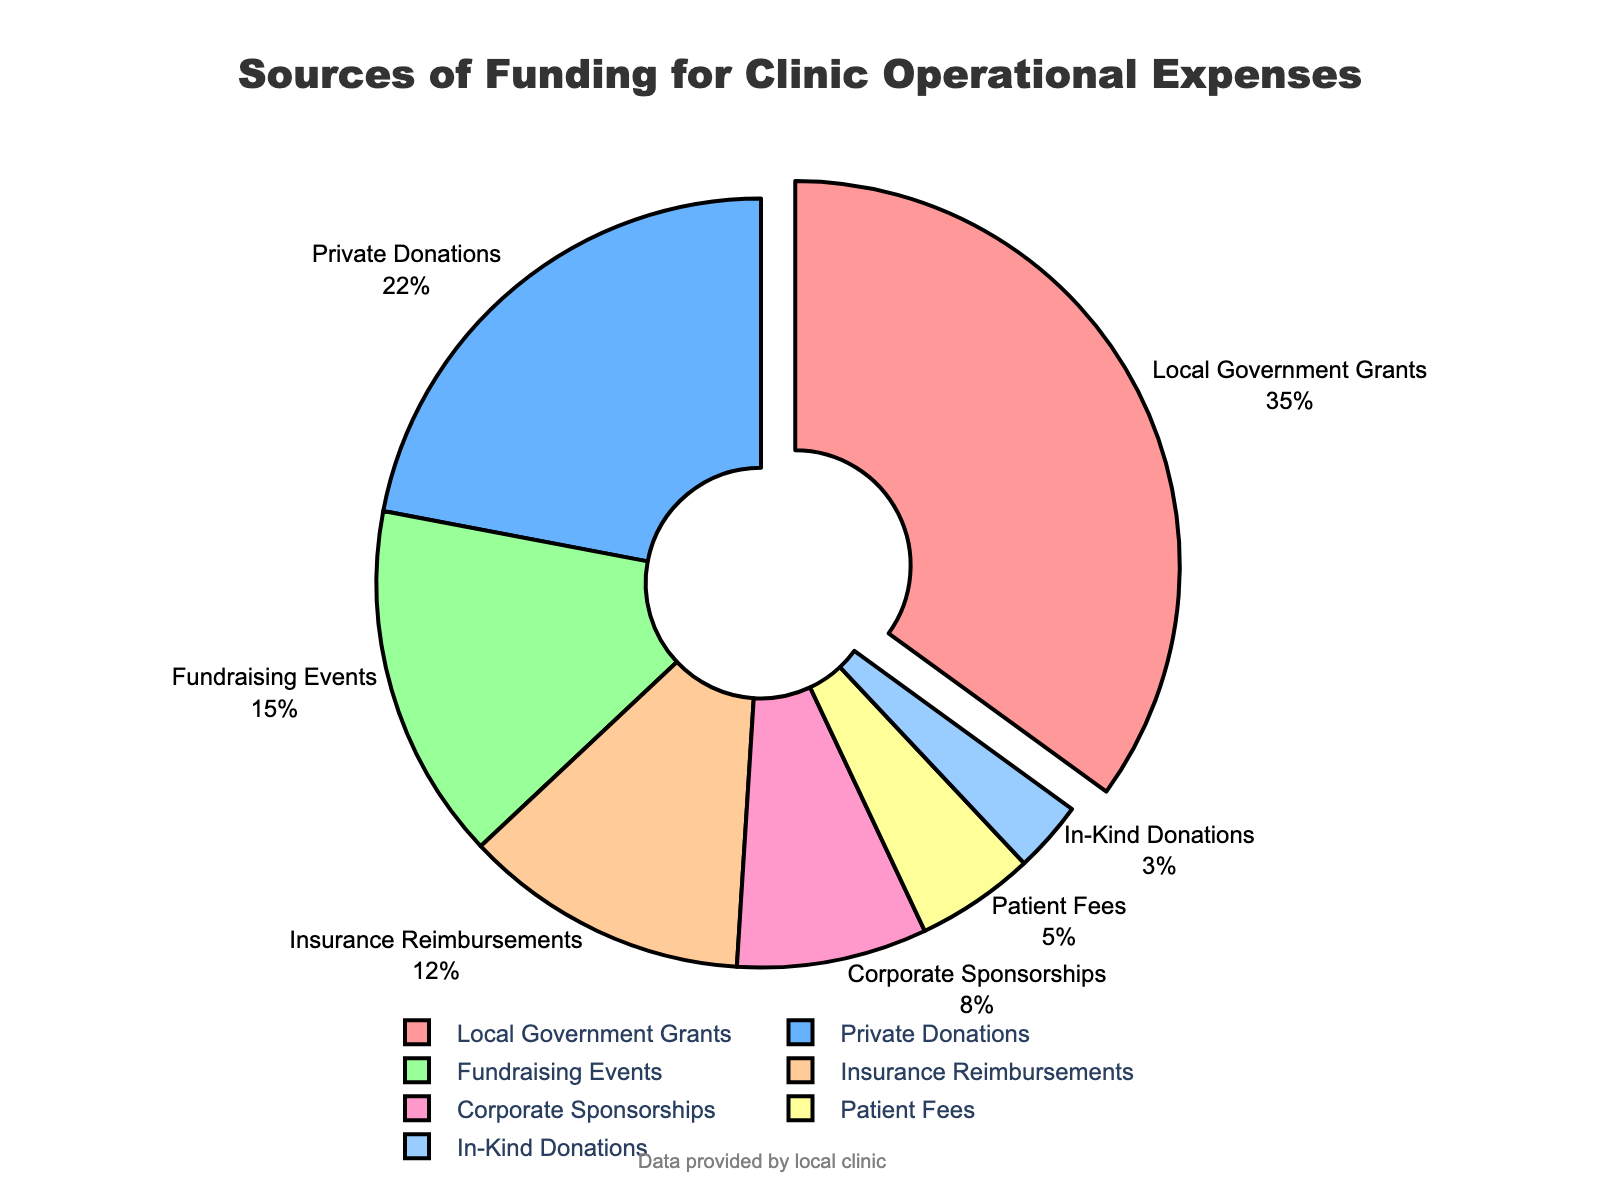What is the largest source of funding for the clinic's operational expenses? The largest source of funding is the section that is pulled out in the pie chart. The label for this section indicates it is "Local Government Grants."
Answer: Local Government Grants What percentage of the funding comes from insurance reimbursements and patient fees combined? Insurance Reimbursements contribute 12% and Patient Fees contribute 5%. Adding them together, we get 12% + 5% = 17%.
Answer: 17% Which source of funding provides less support, corporate sponsorships or patient fees? Comparing Corporate Sponsorships which is 8% and Patient Fees which is 5%, it is clear that Patient Fees provide less support.
Answer: Patient Fees How many sources of funding constitute 50% of the total funding? Local Government Grants provide 35%. Adding Private Donations which is 22%, the sum becomes 57%, exceeding 50%. Therefore, it takes only two sources (Local Government Grants and Private Donations) to exceed 50%.
Answer: 2 What is the ratio of the percentage of funding from private donations to fundraising events? The percentage of funding from Private Donations is 22%, and from Fundraising Events is 15%. The ratio is 22:15.
Answer: 22:15 Is the percentage of funding from in-kind donations less than insurance reimbursements? In-kind Donations contribute 3%, which is less than the 12% from Insurance Reimbursements.
Answer: Yes What color is used to represent corporate sponsorships in the pie chart? Corporate Sponsorships can be identified by their segment in the pie chart. The color for Corporate Sponsorships is in light pink.
Answer: Light pink Which funding source is between corporate sponsorships and patient fees in terms of percentage, and what percentage do they provide? Corporate Sponsorships provide 8% and Patient Fees provide 5%. In-Kind Donations, which is between them in percentage, contributes 3%.
Answer: In-Kind Donations, 3% What is the sum of the percentages from private donations, fundraising events, and insurance reimbursements? Adding Private Donations (22%), Fundraising Events (15%), and Insurance Reimbursements (12%), the sum is 22% + 15% + 12% = 49%.
Answer: 49% If the total operational budget is $100,000, how much funding comes from local government grants? Local Government Grants contribute 35% of the total funding. 35% of $100,000 is calculated as 0.35 * 100,000 = $35,000.
Answer: $35,000 